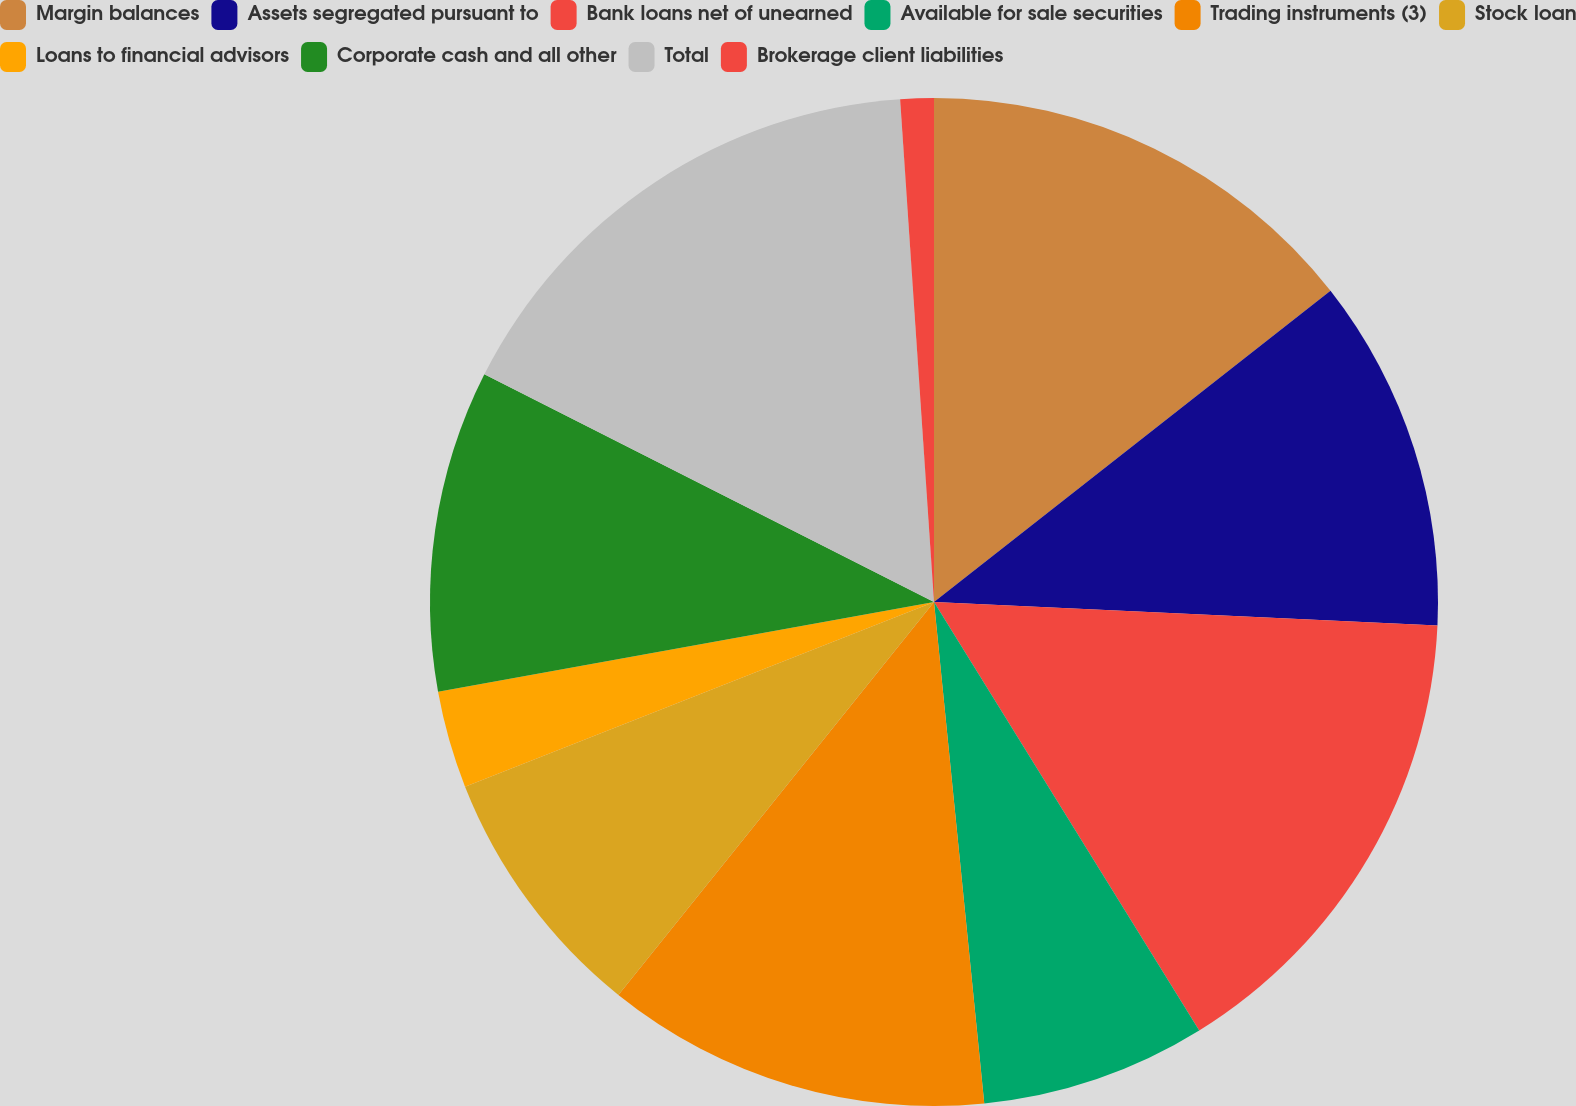<chart> <loc_0><loc_0><loc_500><loc_500><pie_chart><fcel>Margin balances<fcel>Assets segregated pursuant to<fcel>Bank loans net of unearned<fcel>Available for sale securities<fcel>Trading instruments (3)<fcel>Stock loan<fcel>Loans to financial advisors<fcel>Corporate cash and all other<fcel>Total<fcel>Brokerage client liabilities<nl><fcel>14.41%<fcel>11.33%<fcel>15.44%<fcel>7.23%<fcel>12.36%<fcel>8.26%<fcel>3.12%<fcel>10.31%<fcel>16.47%<fcel>1.07%<nl></chart> 